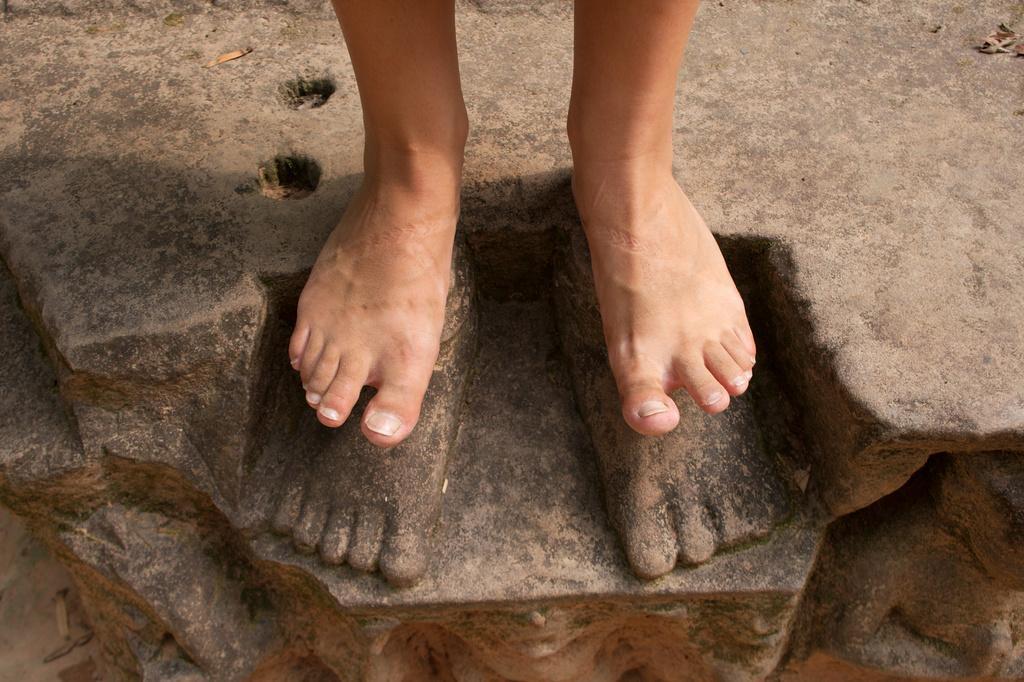Describe this image in one or two sentences. In this image I can see a person standing on the rock. 